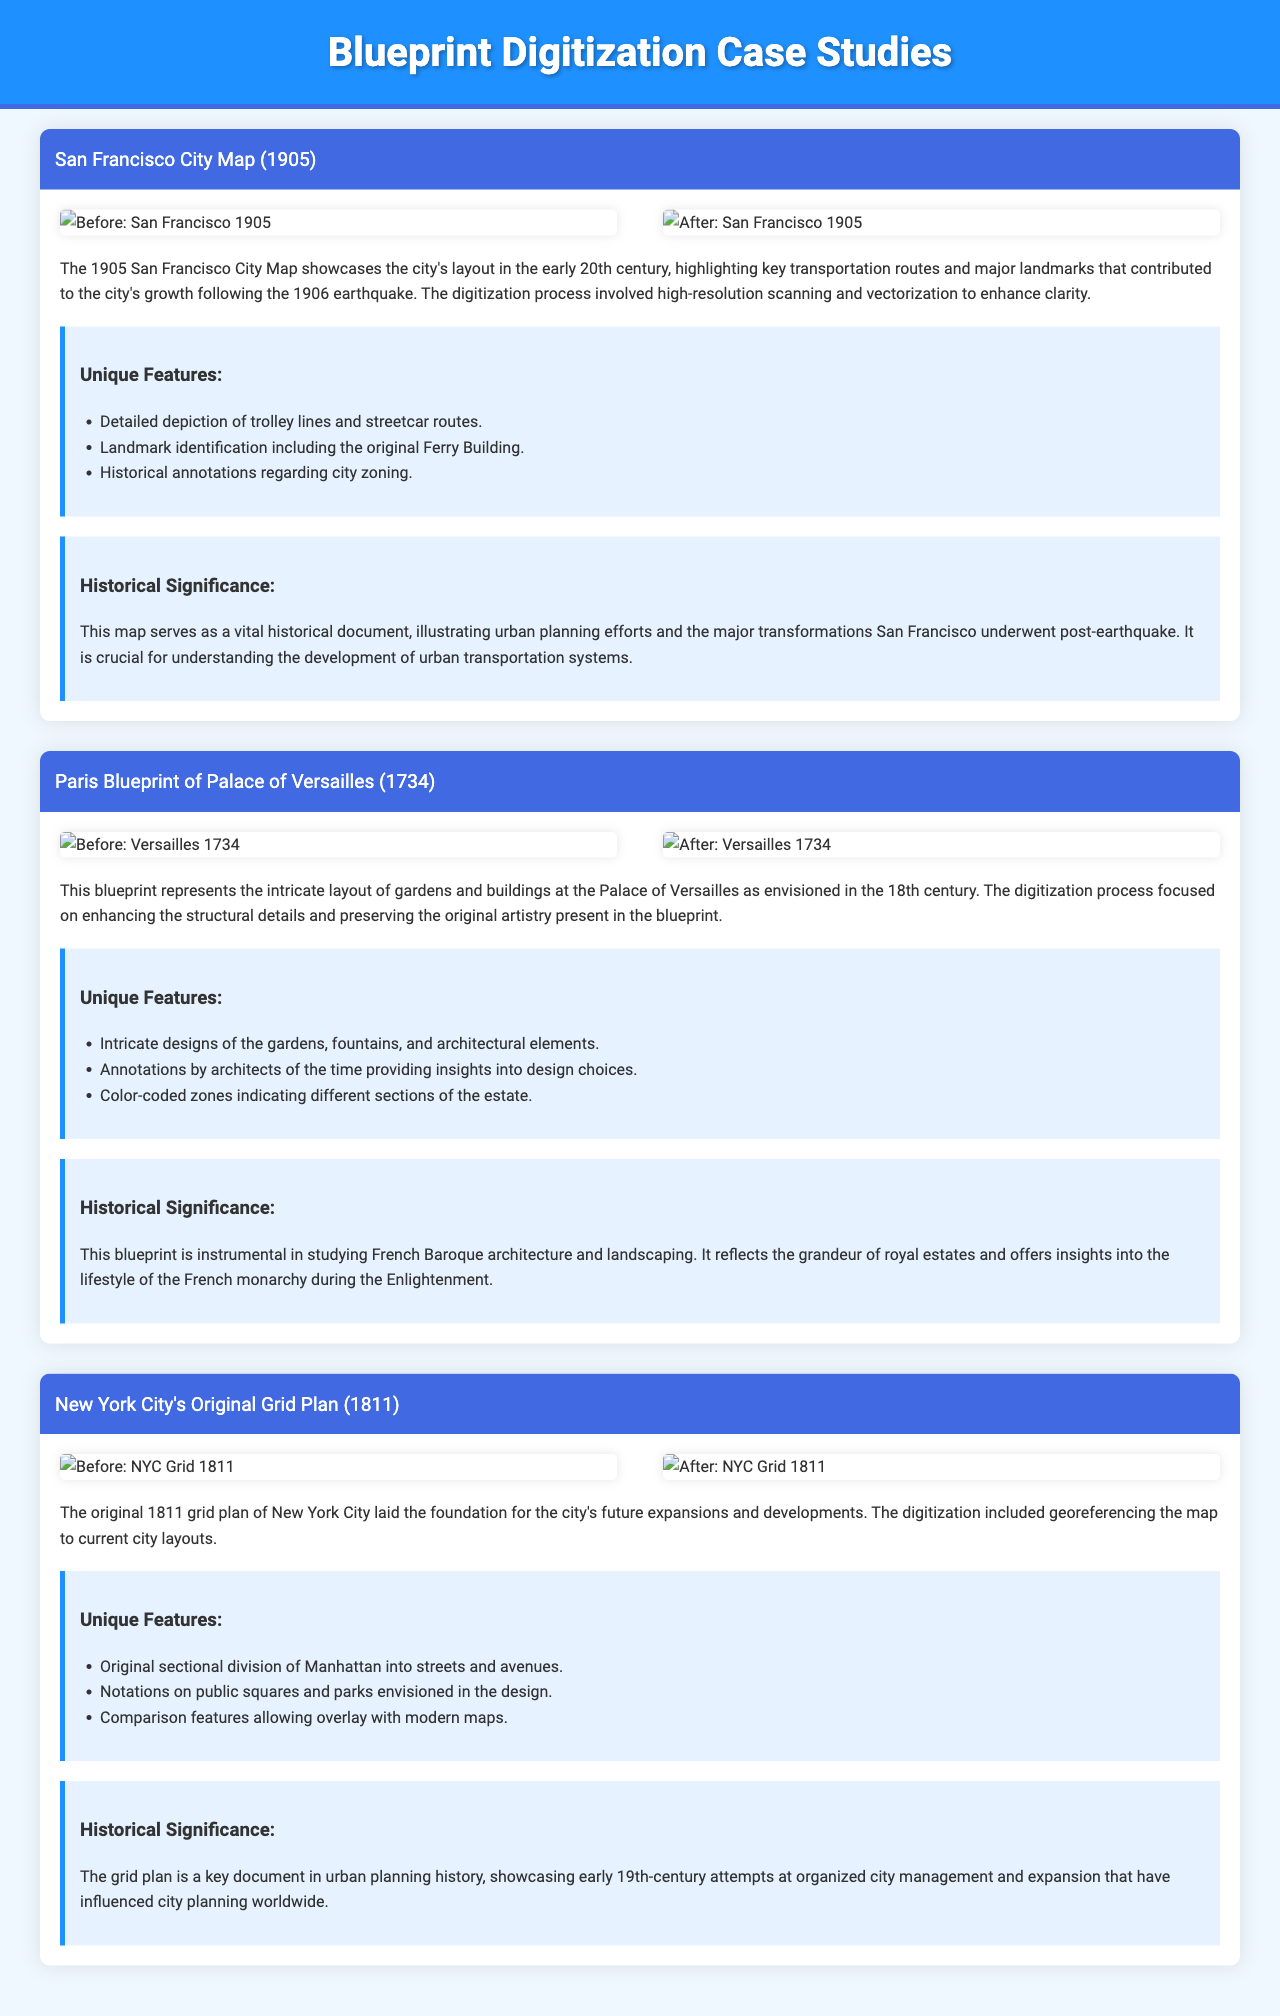What is the name of the first case study? The name of the first case study is the San Francisco City Map (1905).
Answer: San Francisco City Map (1905) How many case studies are presented in the document? There are three case studies presented in the document.
Answer: Three What year was the Paris Blueprint of the Palace of Versailles created? The Paris Blueprint of the Palace of Versailles was created in 1734.
Answer: 1734 What unique feature is highlighted in the New York City's Original Grid Plan? The unique feature highlighted is the original sectional division of Manhattan into streets and avenues.
Answer: Original sectional division of Manhattan into streets and avenues What does the digitization of the 1905 San Francisco City Map enhance? The digitization enhances clarity through high-resolution scanning and vectorization.
Answer: Clarity through high-resolution scanning and vectorization What is the historical significance of the 1811 grid plan of New York City? It showcases early 19th-century attempts at organized city management and expansion.
Answer: Organized city management and expansion What type of architecture does the Versailles blueprint reflect? The Versailles blueprint reflects French Baroque architecture.
Answer: French Baroque architecture Which case study includes color-coded zones? The case study that includes color-coded zones is the Paris Blueprint of Palace of Versailles.
Answer: Paris Blueprint of Palace of Versailles 